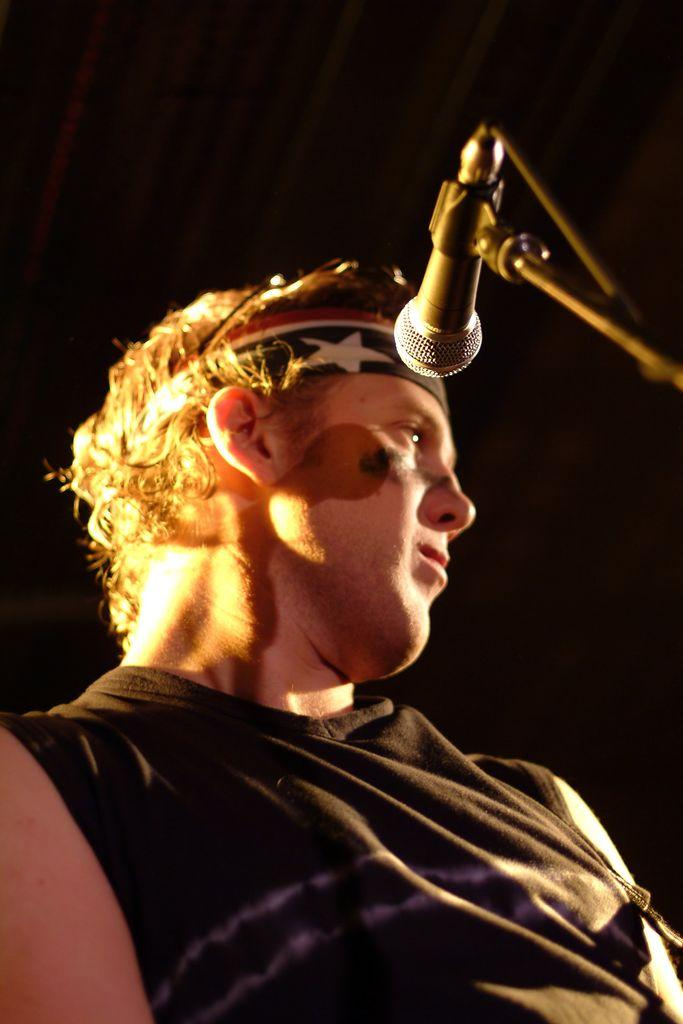Who is present in the image? There is a man in the image. What is the man wearing? The man is wearing a t-shirt. What object can be seen on the right side of the image? There is a microphone on the right side of the image. Is the man taking a hot bath in the image? There is no indication of a bath or any water in the image, and the man is not shown in a bathing situation. 